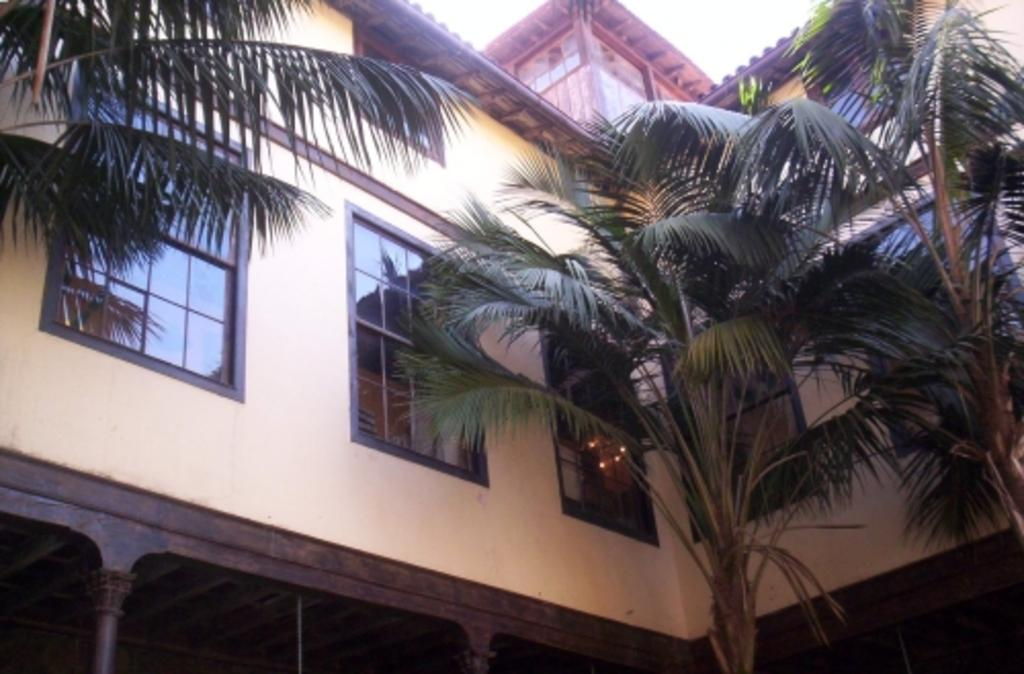What type of structure is present in the image? There is a building in the image. What other natural elements can be seen in the image? There are trees in the image. What part of the environment is visible in the image? The sky is visible in the image. What type of humor can be found in the image? There is no humor present in the image; it is a depiction of a building, trees, and the sky. 